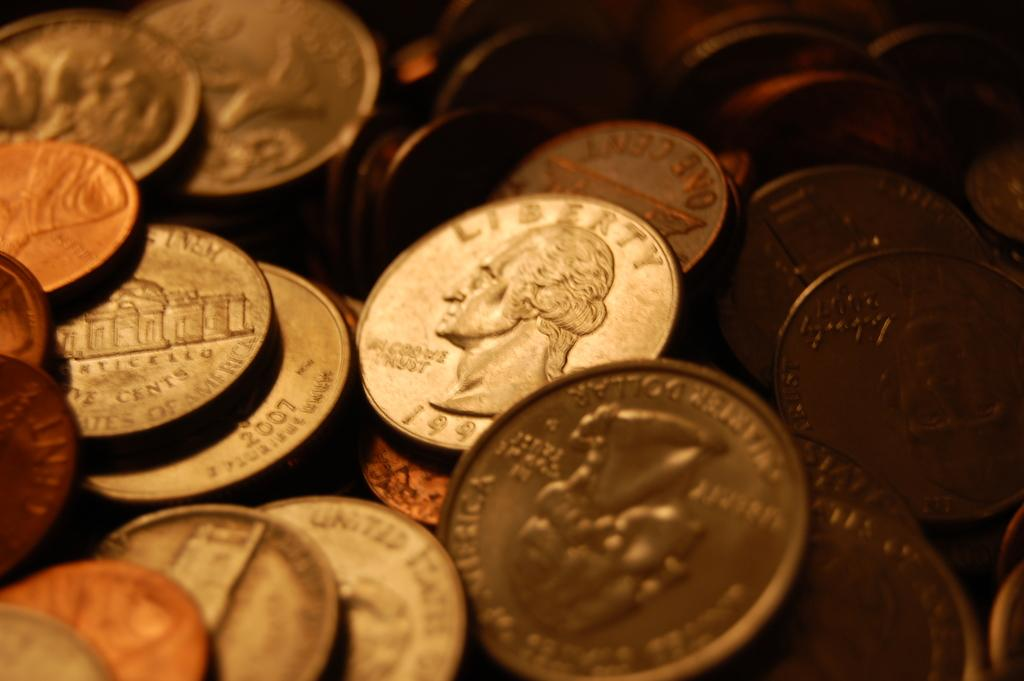<image>
Provide a brief description of the given image. Coin showing a president's head and says Liberty above it. 